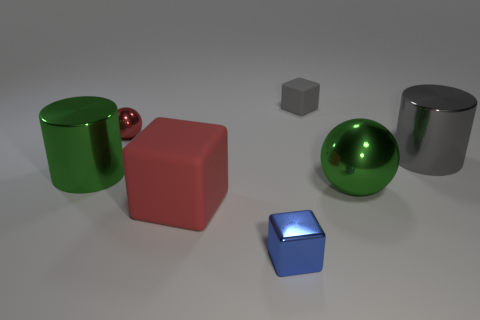What size is the blue metal object that is the same shape as the tiny gray matte object?
Keep it short and to the point. Small. Does the red cube have the same material as the big green thing on the right side of the gray cube?
Offer a terse response. No. How many things are either big green cylinders or brown shiny spheres?
Your answer should be compact. 1. There is a green metallic object that is on the right side of the big red object; does it have the same size as the gray thing that is in front of the small red ball?
Offer a terse response. Yes. How many balls are either gray rubber objects or large rubber objects?
Offer a terse response. 0. Are there any tiny balls?
Make the answer very short. Yes. Are there any other things that have the same shape as the big gray object?
Offer a very short reply. Yes. Is the color of the tiny rubber thing the same as the tiny shiny block?
Ensure brevity in your answer.  No. What number of objects are either balls that are right of the small red thing or tiny spheres?
Keep it short and to the point. 2. What number of small metallic objects are behind the tiny gray matte cube behind the metallic cylinder to the left of the large gray metallic thing?
Offer a terse response. 0. 